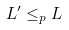<formula> <loc_0><loc_0><loc_500><loc_500>L ^ { \prime } \leq _ { p } L</formula> 